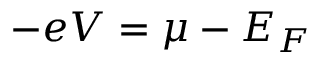<formula> <loc_0><loc_0><loc_500><loc_500>- e V = \mu - E _ { F }</formula> 